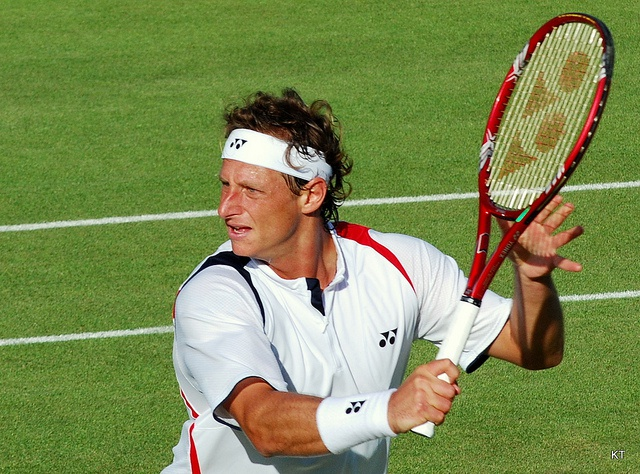Describe the objects in this image and their specific colors. I can see people in olive, lightgray, black, brown, and salmon tones and tennis racket in olive, maroon, and ivory tones in this image. 